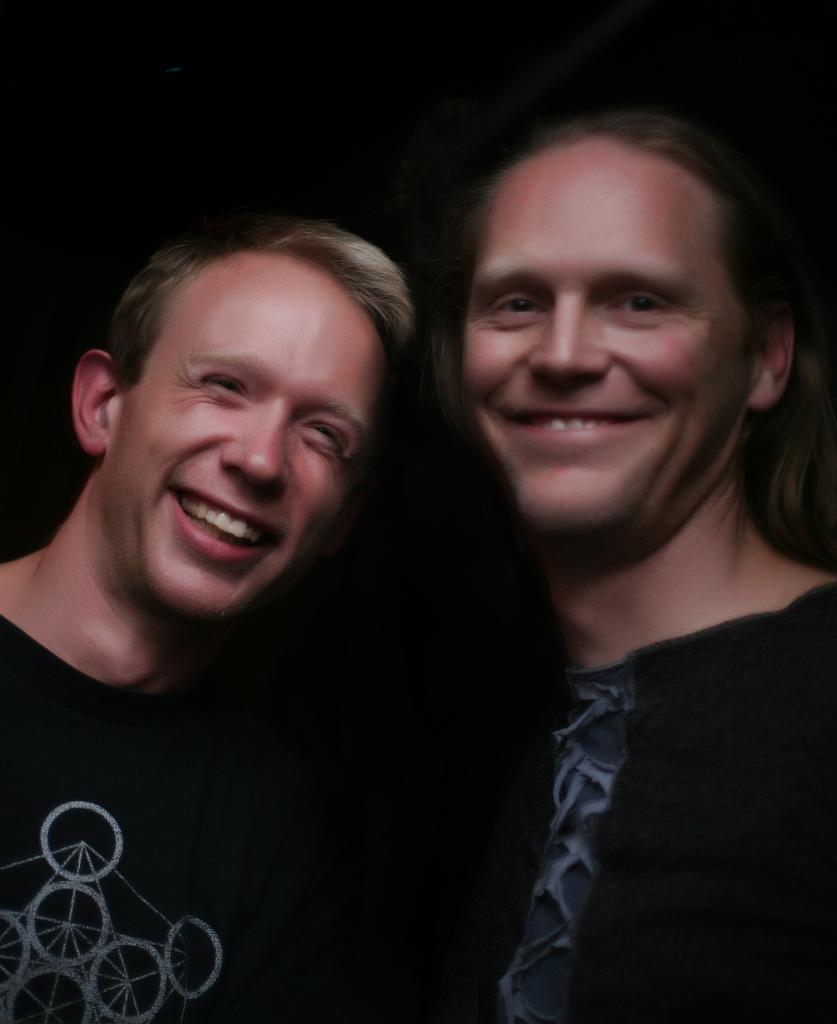How many people are in the image? There are two persons in the image. What are the two persons doing in the image? The two persons are standing. What can be observed about the background of the image? The backdrop of the image is dark. What type of mint is being used as bait by the persons in the image? There is no mint or bait present in the image; the two persons are simply standing. 